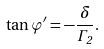<formula> <loc_0><loc_0><loc_500><loc_500>\tan \varphi ^ { \prime } = - \frac { \delta } { \Gamma _ { 2 } } .</formula> 